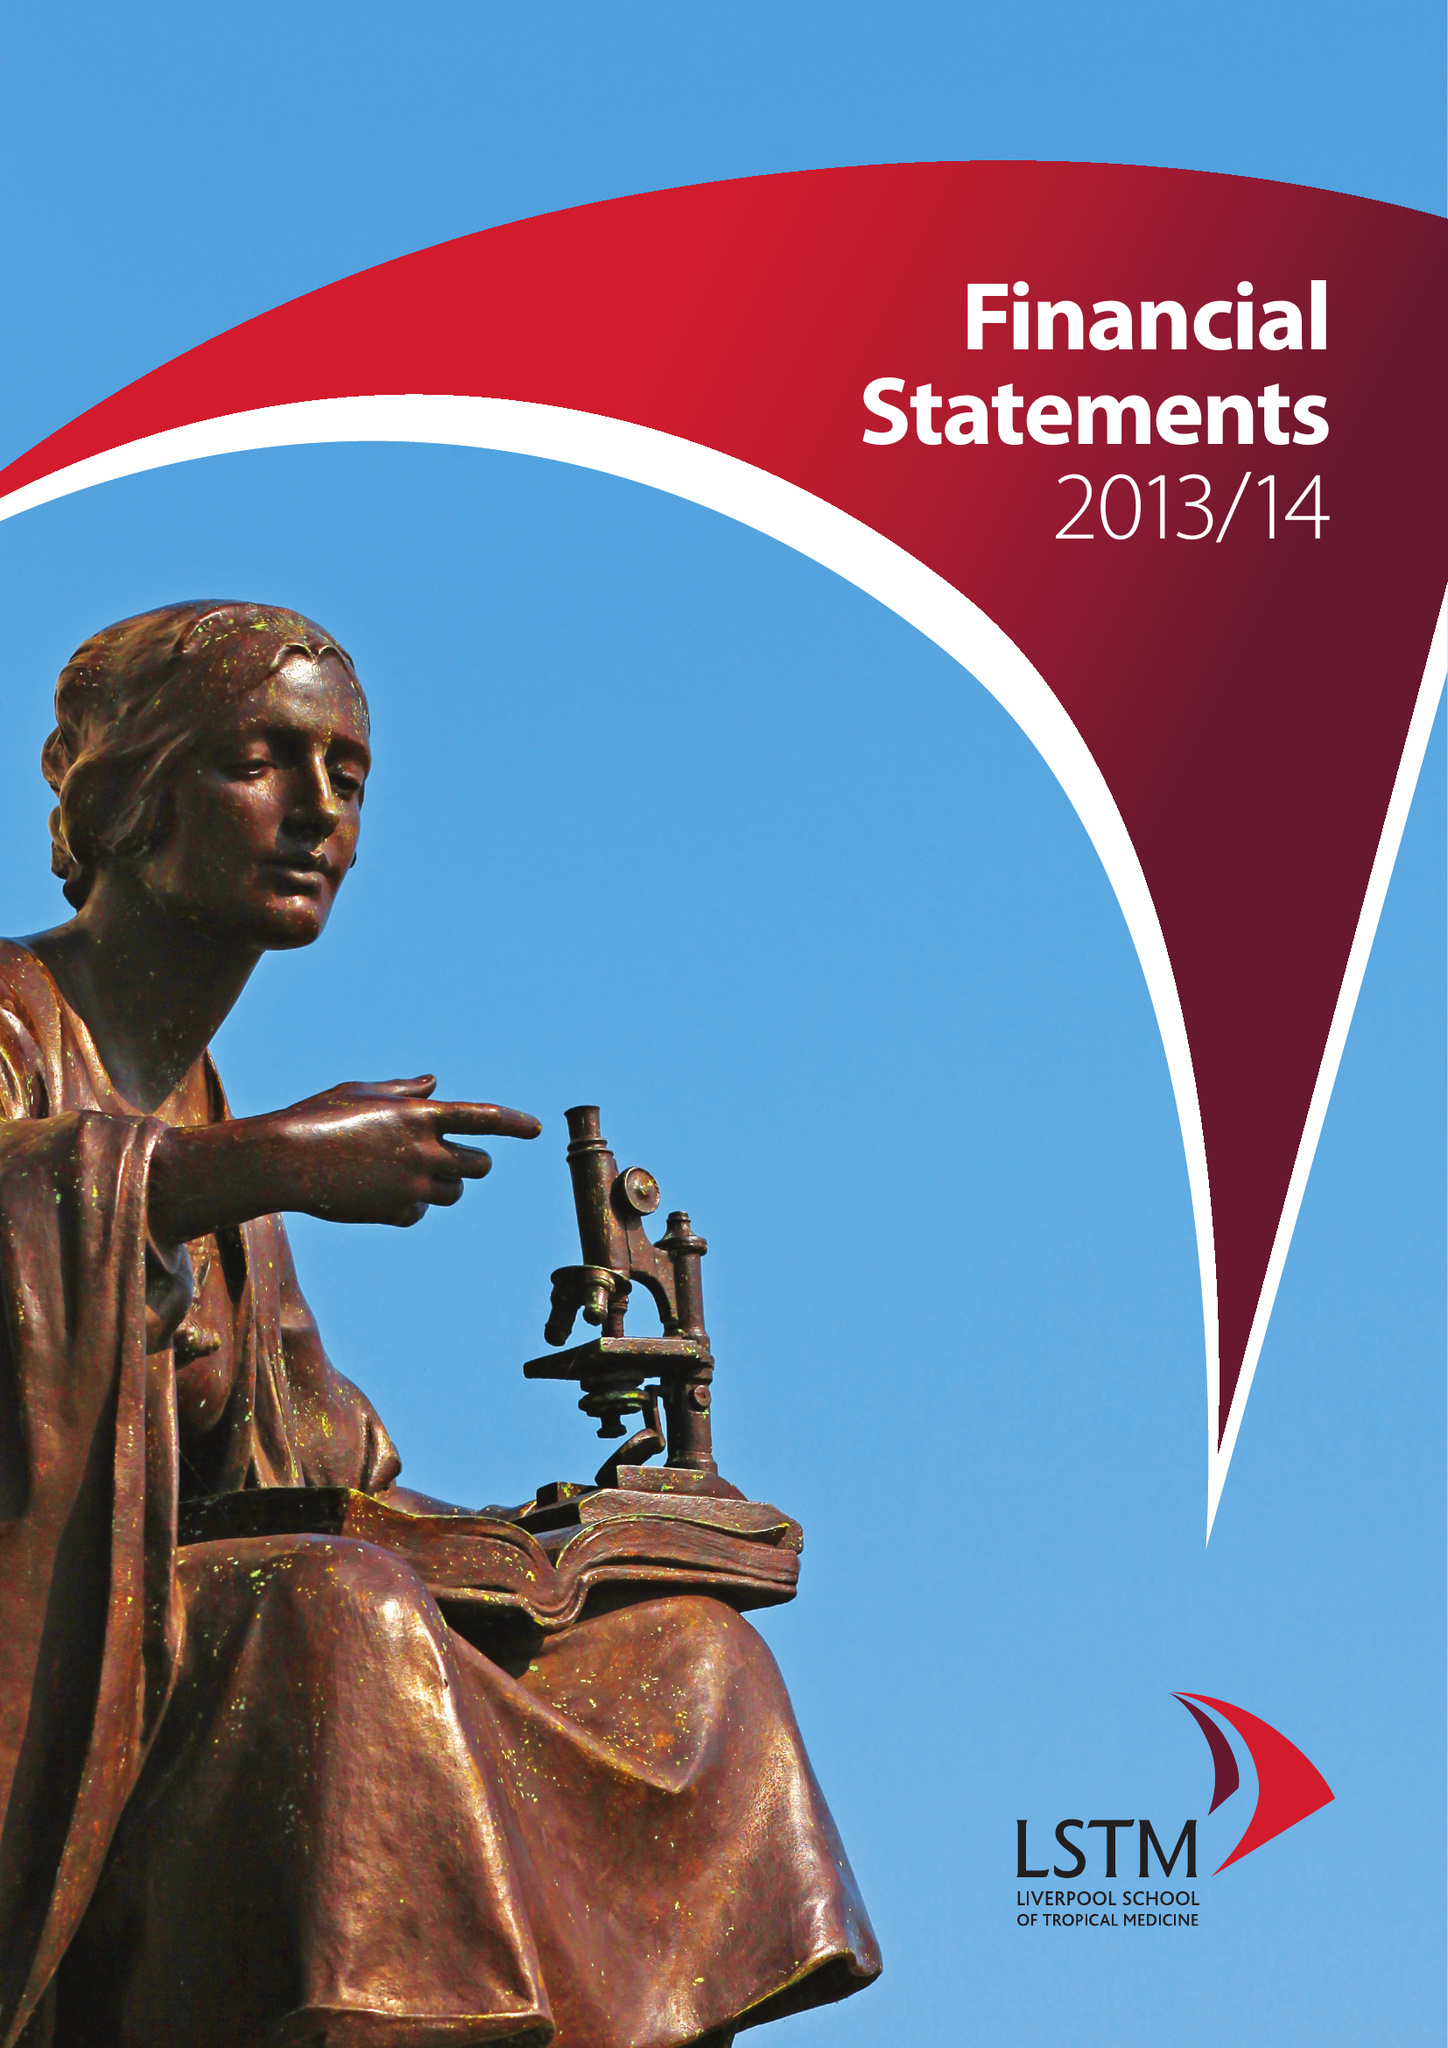What is the value for the address__post_town?
Answer the question using a single word or phrase. LIVERPOOL 